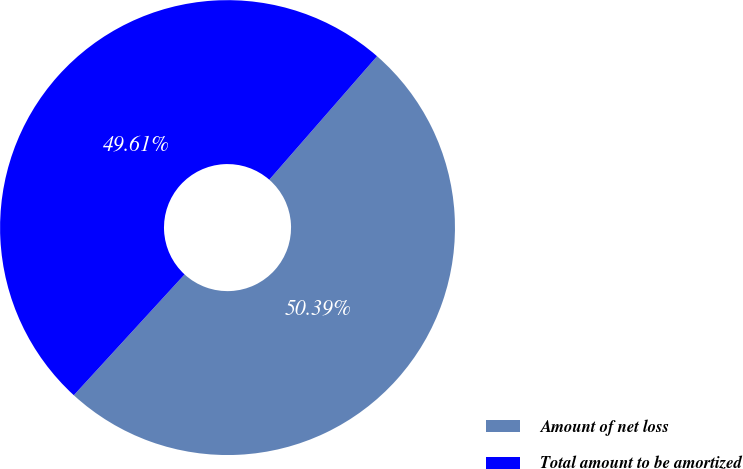Convert chart. <chart><loc_0><loc_0><loc_500><loc_500><pie_chart><fcel>Amount of net loss<fcel>Total amount to be amortized<nl><fcel>50.39%<fcel>49.61%<nl></chart> 